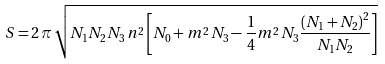<formula> <loc_0><loc_0><loc_500><loc_500>S = 2 \, \pi \, \sqrt { N _ { 1 } N _ { 2 } N _ { 3 } \, n ^ { 2 } \left [ N _ { 0 } + m ^ { 2 } \, N _ { 3 } - \frac { 1 } { 4 } m ^ { 2 } \, N _ { 3 } \frac { \left ( N _ { 1 } + N _ { 2 } \right ) ^ { 2 } } { N _ { 1 } N _ { 2 } } \right ] }</formula> 